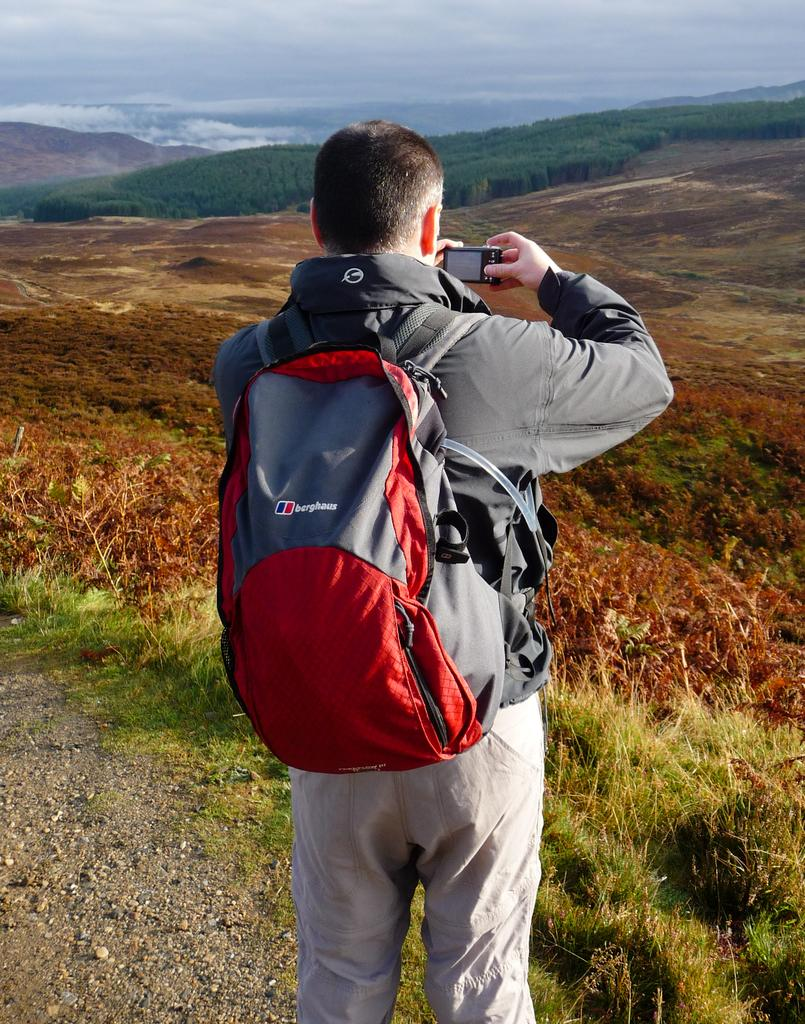Provide a one-sentence caption for the provided image. Man wearing an orange berghaus backpack taking a photo. 